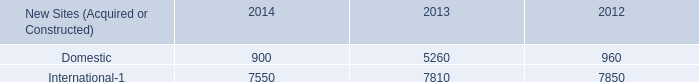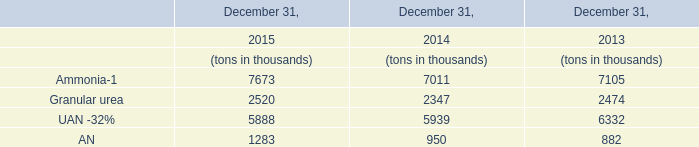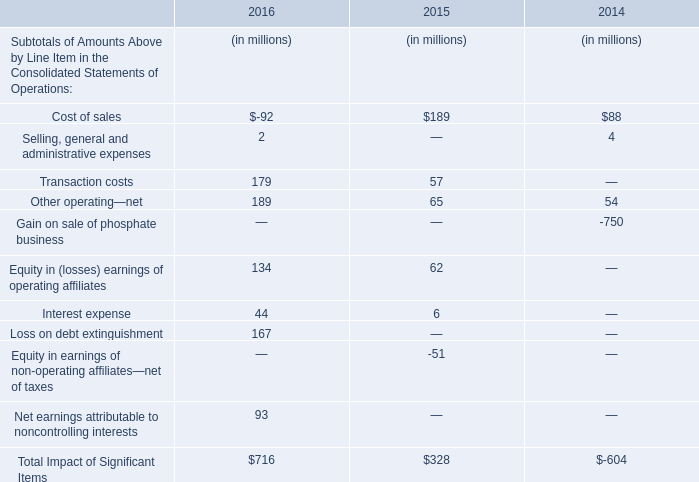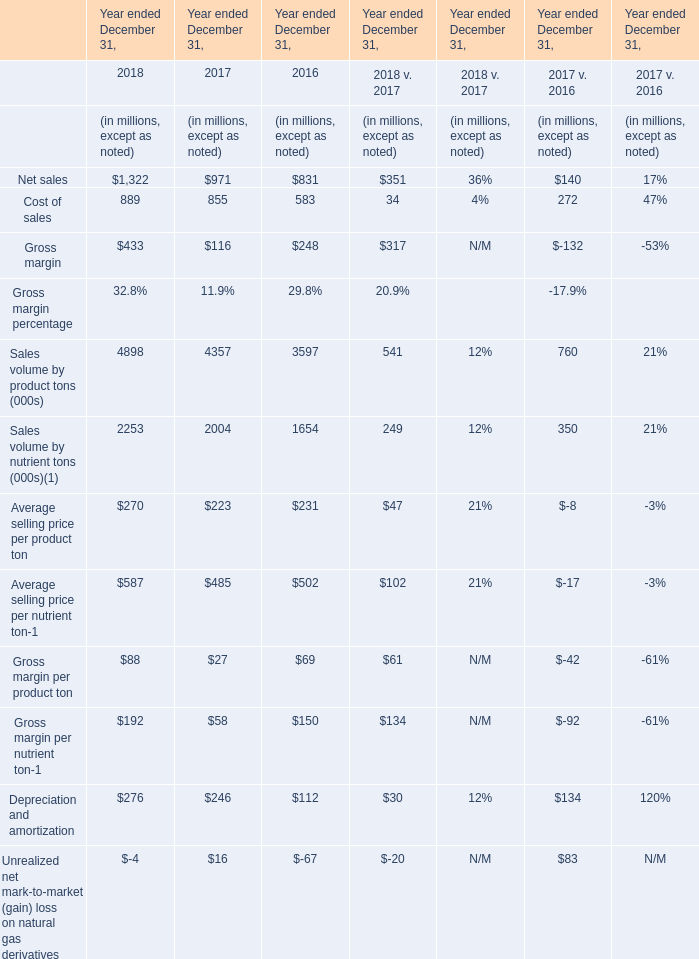In the year/section with the most 2018, what is the growth rate of Cost of sales? 
Computations: ((889 - 855) / 889)
Answer: 0.03825. 